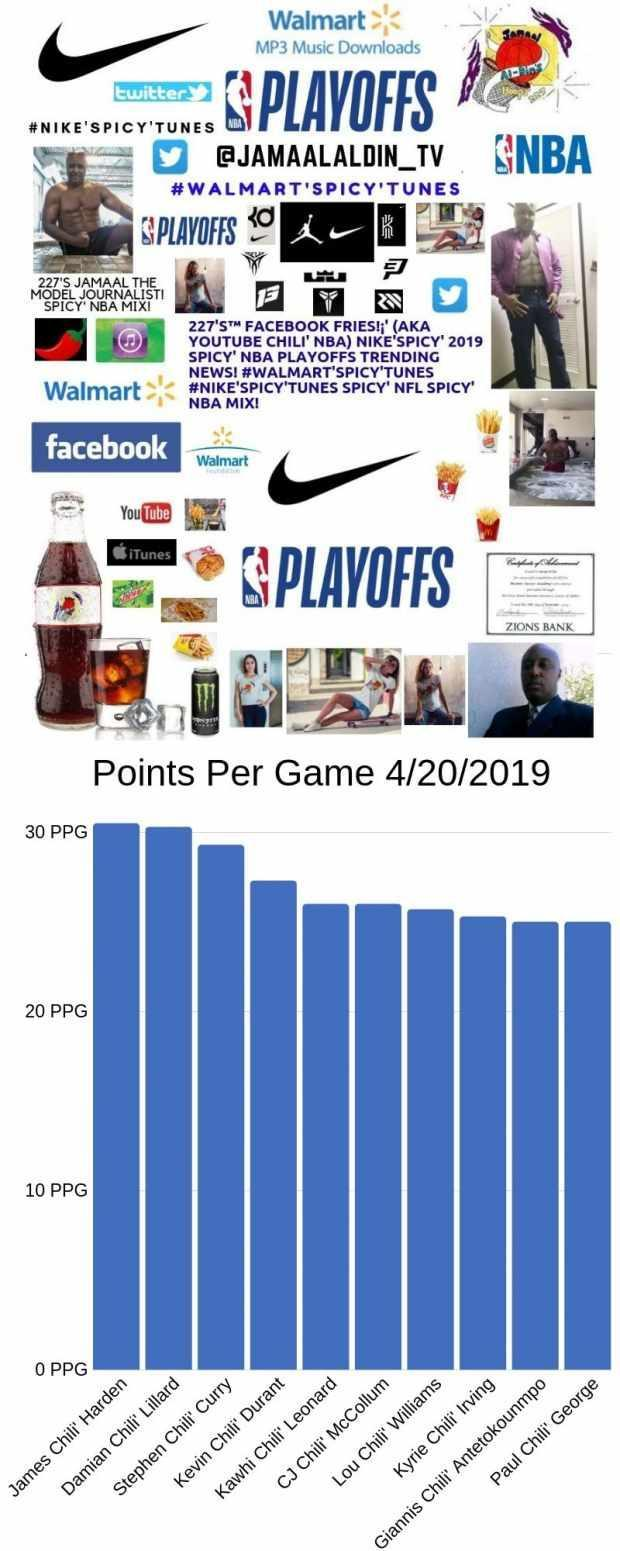Who have the top 3 PPG?
Answer the question with a short phrase. James Chili' Harden, Damian Chili' Lillard, Stephen Chili' Curry 